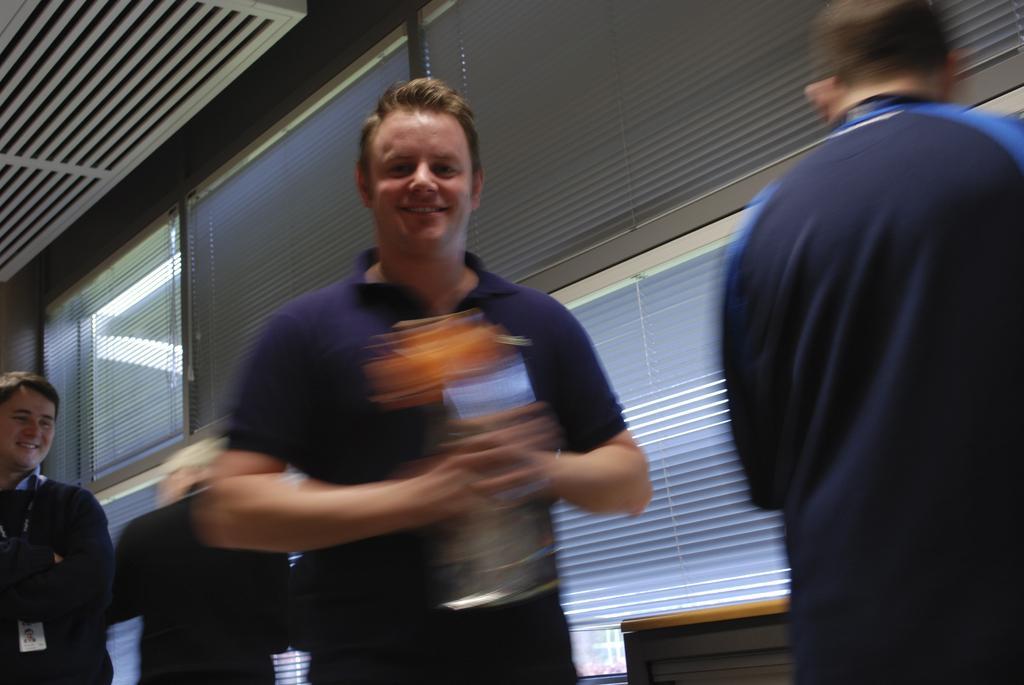Please provide a concise description of this image. In this picture we can see a person holding something and smiling at someone. In the background, we can see other people standing near the table and glass windows. 